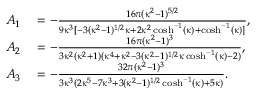Convert formula to latex. <formula><loc_0><loc_0><loc_500><loc_500>\begin{array} { r l } { A _ { 1 } } & = - \frac { 1 6 \pi ( \kappa ^ { 2 } - 1 ) ^ { 5 / 2 } } { 9 \kappa ^ { 3 } [ - 3 ( \kappa ^ { 2 } - 1 ) ^ { 1 / 2 } \kappa + 2 \kappa ^ { 2 } \cosh ^ { - 1 } ( \kappa ) + \cosh ^ { - 1 } ( \kappa ) ] } , } \\ { A _ { 2 } } & = - \frac { 1 6 \pi ( \kappa ^ { 2 } - 1 ) ^ { 3 } } { 3 \kappa ^ { 2 } ( \kappa ^ { 2 } + 1 ) ( \kappa ^ { 4 } + \kappa ^ { 2 } - 3 ( \kappa ^ { 2 } - 1 ) ^ { 1 / 2 } \kappa \cosh ^ { - 1 } ( \kappa ) - 2 ) } , } \\ { A _ { 3 } } & = - \frac { 3 2 \pi ( \kappa ^ { 2 } - 1 ) ^ { 3 } } { 3 \kappa ^ { 3 } ( 2 \kappa ^ { 5 } - 7 \kappa ^ { 3 } + 3 ( \kappa ^ { 2 } - 1 ) ^ { 1 / 2 } \cosh ^ { - 1 } ( \kappa ) + 5 \kappa ) } . } \end{array}</formula> 